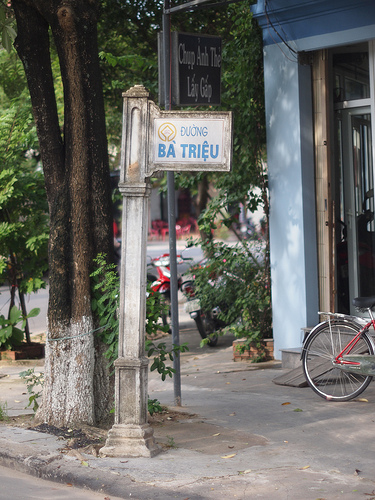Please provide a short description for this region: [0.43, 0.22, 0.57, 0.34]. The region [0.43, 0.22, 0.57, 0.34] contains a blue and white sign. 